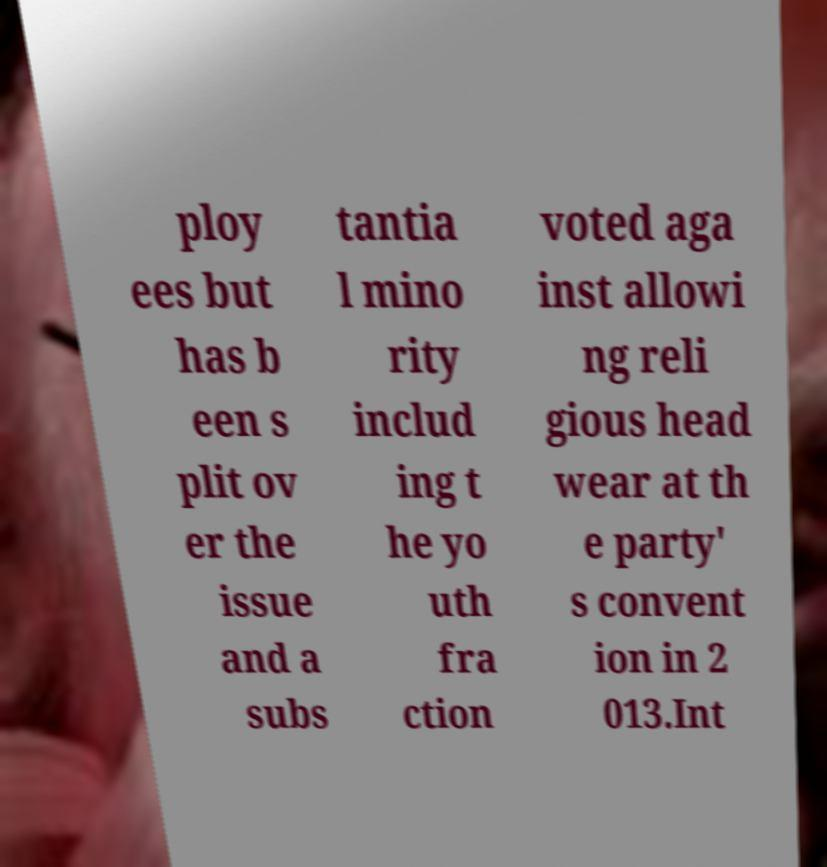Please identify and transcribe the text found in this image. ploy ees but has b een s plit ov er the issue and a subs tantia l mino rity includ ing t he yo uth fra ction voted aga inst allowi ng reli gious head wear at th e party' s convent ion in 2 013.Int 